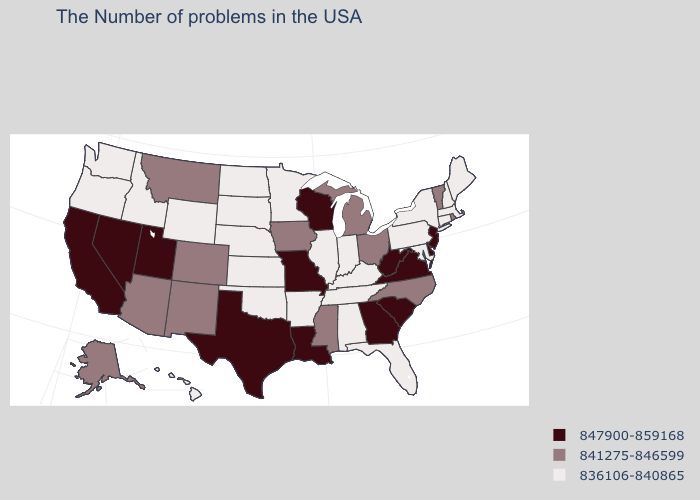Is the legend a continuous bar?
Short answer required. No. What is the highest value in the MidWest ?
Concise answer only. 847900-859168. What is the value of Colorado?
Concise answer only. 841275-846599. What is the highest value in the MidWest ?
Short answer required. 847900-859168. What is the lowest value in the Northeast?
Short answer required. 836106-840865. Is the legend a continuous bar?
Give a very brief answer. No. What is the value of Arizona?
Give a very brief answer. 841275-846599. Does Colorado have the highest value in the West?
Give a very brief answer. No. Which states have the lowest value in the USA?
Short answer required. Maine, Massachusetts, New Hampshire, Connecticut, New York, Maryland, Pennsylvania, Florida, Kentucky, Indiana, Alabama, Tennessee, Illinois, Arkansas, Minnesota, Kansas, Nebraska, Oklahoma, South Dakota, North Dakota, Wyoming, Idaho, Washington, Oregon, Hawaii. Does Maryland have a lower value than Kentucky?
Concise answer only. No. What is the value of Pennsylvania?
Keep it brief. 836106-840865. What is the value of Iowa?
Be succinct. 841275-846599. What is the highest value in the USA?
Be succinct. 847900-859168. Among the states that border Wyoming , does Utah have the highest value?
Be succinct. Yes. Does Wyoming have the highest value in the USA?
Quick response, please. No. 